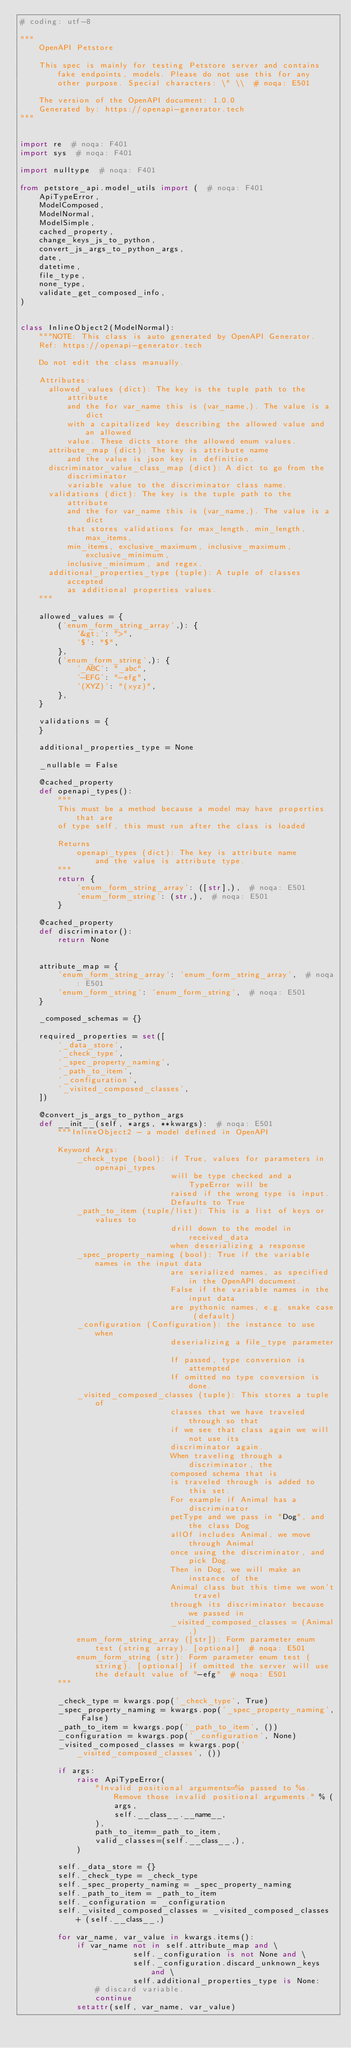Convert code to text. <code><loc_0><loc_0><loc_500><loc_500><_Python_># coding: utf-8

"""
    OpenAPI Petstore

    This spec is mainly for testing Petstore server and contains fake endpoints, models. Please do not use this for any other purpose. Special characters: \" \\  # noqa: E501

    The version of the OpenAPI document: 1.0.0
    Generated by: https://openapi-generator.tech
"""


import re  # noqa: F401
import sys  # noqa: F401

import nulltype  # noqa: F401

from petstore_api.model_utils import (  # noqa: F401
    ApiTypeError,
    ModelComposed,
    ModelNormal,
    ModelSimple,
    cached_property,
    change_keys_js_to_python,
    convert_js_args_to_python_args,
    date,
    datetime,
    file_type,
    none_type,
    validate_get_composed_info,
)


class InlineObject2(ModelNormal):
    """NOTE: This class is auto generated by OpenAPI Generator.
    Ref: https://openapi-generator.tech

    Do not edit the class manually.

    Attributes:
      allowed_values (dict): The key is the tuple path to the attribute
          and the for var_name this is (var_name,). The value is a dict
          with a capitalized key describing the allowed value and an allowed
          value. These dicts store the allowed enum values.
      attribute_map (dict): The key is attribute name
          and the value is json key in definition.
      discriminator_value_class_map (dict): A dict to go from the discriminator
          variable value to the discriminator class name.
      validations (dict): The key is the tuple path to the attribute
          and the for var_name this is (var_name,). The value is a dict
          that stores validations for max_length, min_length, max_items,
          min_items, exclusive_maximum, inclusive_maximum, exclusive_minimum,
          inclusive_minimum, and regex.
      additional_properties_type (tuple): A tuple of classes accepted
          as additional properties values.
    """

    allowed_values = {
        ('enum_form_string_array',): {
            '&gt;': ">",
            '$': "$",
        },
        ('enum_form_string',): {
            '_ABC': "_abc",
            '-EFG': "-efg",
            '(XYZ)': "(xyz)",
        },
    }

    validations = {
    }

    additional_properties_type = None

    _nullable = False

    @cached_property
    def openapi_types():
        """
        This must be a method because a model may have properties that are
        of type self, this must run after the class is loaded

        Returns
            openapi_types (dict): The key is attribute name
                and the value is attribute type.
        """
        return {
            'enum_form_string_array': ([str],),  # noqa: E501
            'enum_form_string': (str,),  # noqa: E501
        }

    @cached_property
    def discriminator():
        return None


    attribute_map = {
        'enum_form_string_array': 'enum_form_string_array',  # noqa: E501
        'enum_form_string': 'enum_form_string',  # noqa: E501
    }

    _composed_schemas = {}

    required_properties = set([
        '_data_store',
        '_check_type',
        '_spec_property_naming',
        '_path_to_item',
        '_configuration',
        '_visited_composed_classes',
    ])

    @convert_js_args_to_python_args
    def __init__(self, *args, **kwargs):  # noqa: E501
        """InlineObject2 - a model defined in OpenAPI

        Keyword Args:
            _check_type (bool): if True, values for parameters in openapi_types
                                will be type checked and a TypeError will be
                                raised if the wrong type is input.
                                Defaults to True
            _path_to_item (tuple/list): This is a list of keys or values to
                                drill down to the model in received_data
                                when deserializing a response
            _spec_property_naming (bool): True if the variable names in the input data
                                are serialized names, as specified in the OpenAPI document.
                                False if the variable names in the input data
                                are pythonic names, e.g. snake case (default)
            _configuration (Configuration): the instance to use when
                                deserializing a file_type parameter.
                                If passed, type conversion is attempted
                                If omitted no type conversion is done.
            _visited_composed_classes (tuple): This stores a tuple of
                                classes that we have traveled through so that
                                if we see that class again we will not use its
                                discriminator again.
                                When traveling through a discriminator, the
                                composed schema that is
                                is traveled through is added to this set.
                                For example if Animal has a discriminator
                                petType and we pass in "Dog", and the class Dog
                                allOf includes Animal, we move through Animal
                                once using the discriminator, and pick Dog.
                                Then in Dog, we will make an instance of the
                                Animal class but this time we won't travel
                                through its discriminator because we passed in
                                _visited_composed_classes = (Animal,)
            enum_form_string_array ([str]): Form parameter enum test (string array). [optional]  # noqa: E501
            enum_form_string (str): Form parameter enum test (string). [optional] if omitted the server will use the default value of "-efg"  # noqa: E501
        """

        _check_type = kwargs.pop('_check_type', True)
        _spec_property_naming = kwargs.pop('_spec_property_naming', False)
        _path_to_item = kwargs.pop('_path_to_item', ())
        _configuration = kwargs.pop('_configuration', None)
        _visited_composed_classes = kwargs.pop('_visited_composed_classes', ())

        if args:
            raise ApiTypeError(
                "Invalid positional arguments=%s passed to %s. Remove those invalid positional arguments." % (
                    args,
                    self.__class__.__name__,
                ),
                path_to_item=_path_to_item,
                valid_classes=(self.__class__,),
            )

        self._data_store = {}
        self._check_type = _check_type
        self._spec_property_naming = _spec_property_naming
        self._path_to_item = _path_to_item
        self._configuration = _configuration
        self._visited_composed_classes = _visited_composed_classes + (self.__class__,)

        for var_name, var_value in kwargs.items():
            if var_name not in self.attribute_map and \
                        self._configuration is not None and \
                        self._configuration.discard_unknown_keys and \
                        self.additional_properties_type is None:
                # discard variable.
                continue
            setattr(self, var_name, var_value)
</code> 